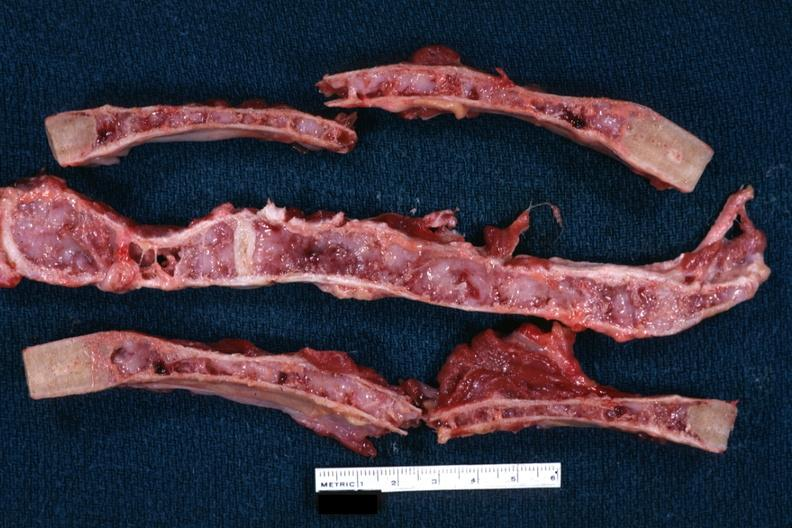where is this?
Answer the question using a single word or phrase. Thorax 